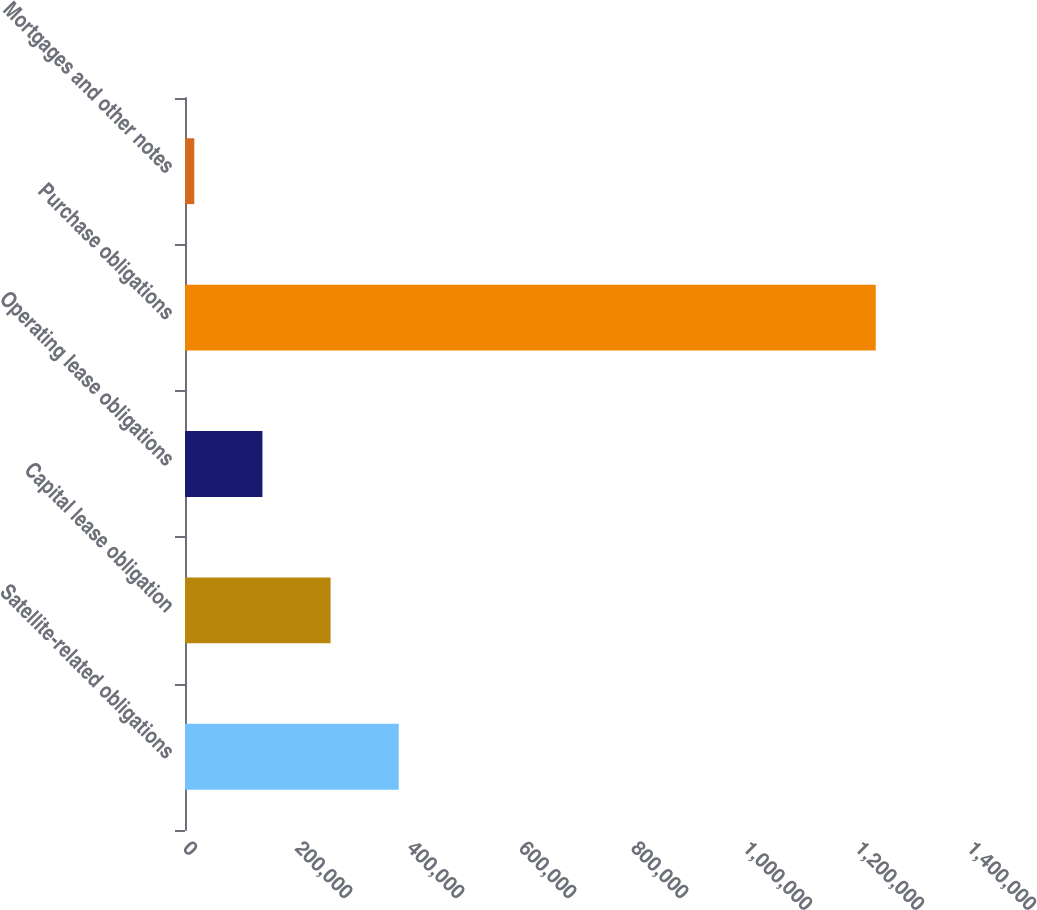Convert chart. <chart><loc_0><loc_0><loc_500><loc_500><bar_chart><fcel>Satellite-related obligations<fcel>Capital lease obligation<fcel>Operating lease obligations<fcel>Purchase obligations<fcel>Mortgages and other notes<nl><fcel>381650<fcel>259967<fcel>138283<fcel>1.23344e+06<fcel>16599<nl></chart> 